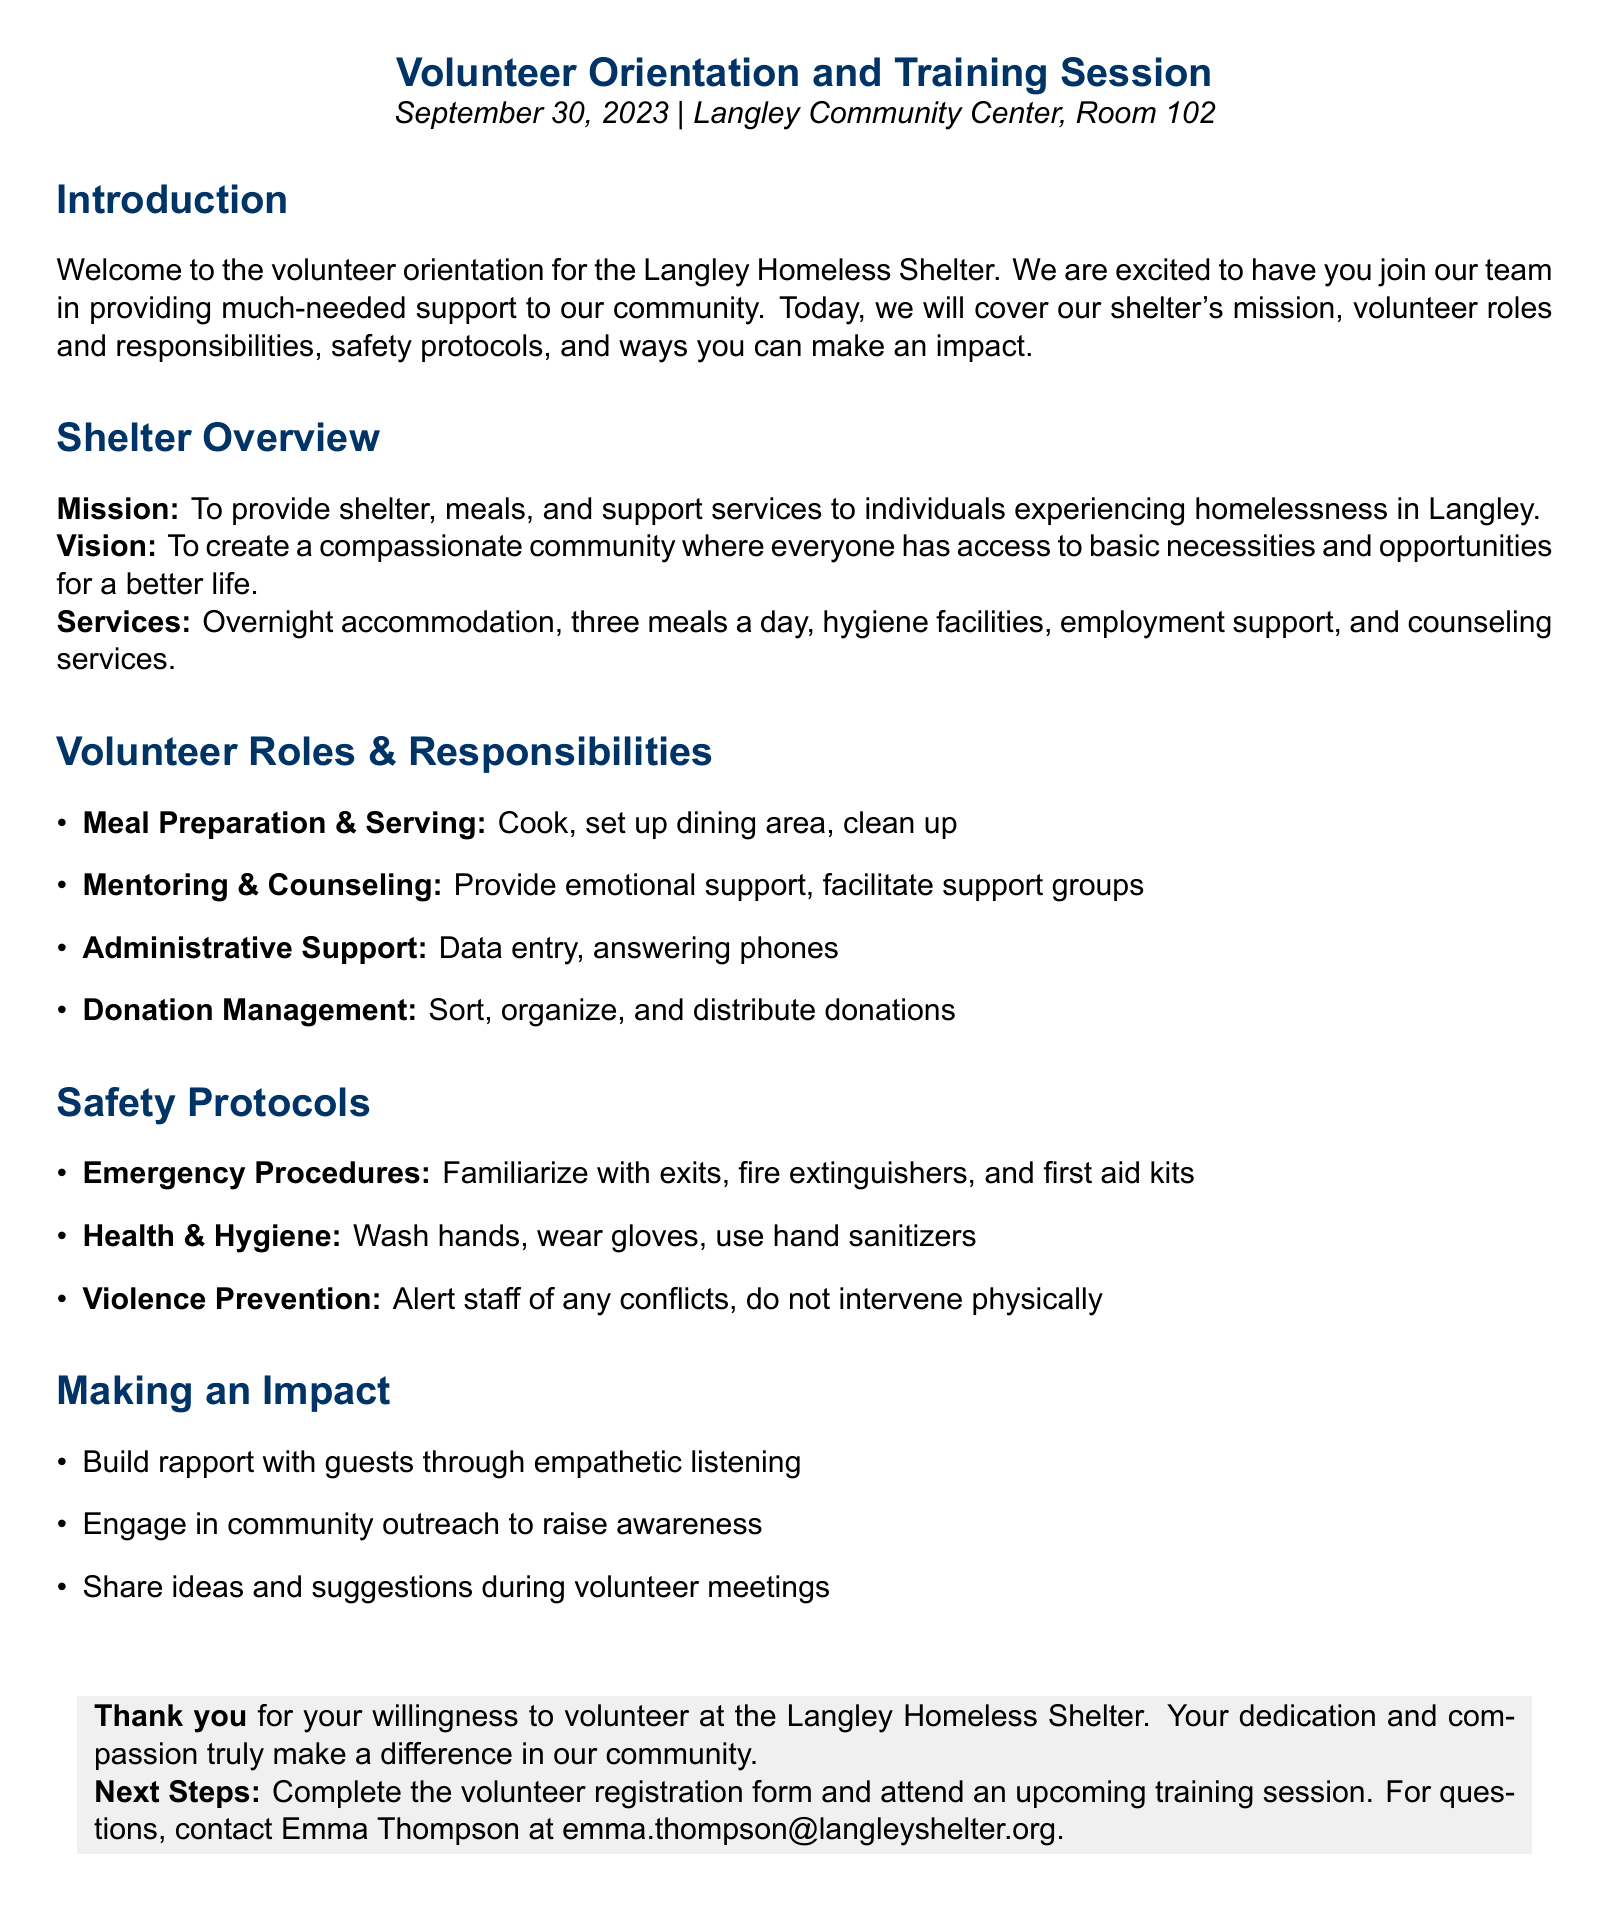What is the date of the orientation? The orientation is scheduled for September 30, 2023.
Answer: September 30, 2023 What is the mission of the shelter? The mission is to provide shelter, meals, and support services to individuals experiencing homelessness in Langley.
Answer: To provide shelter, meals, and support services What role involves cooking and serving food? This role is categorized under Meal Preparation & Serving.
Answer: Meal Preparation & Serving Who should you contact for questions? The contact person for questions is Emma Thompson.
Answer: Emma Thompson What type of support does the shelter offer? Services include overnight accommodation, three meals a day, hygiene facilities, employment support, and counseling services.
Answer: Overnight accommodation, three meals a day, hygiene facilities, employment support, and counseling services What should volunteers familiarize themselves with during emergency procedures? Volunteers should familiarize themselves with exits, fire extinguishers, and first aid kits.
Answer: Exits, fire extinguishers, and first aid kits What is one way volunteers can make an impact? One way to make an impact is to build rapport with guests through empathetic listening.
Answer: Build rapport with guests through empathetic listening What is required to proceed after the orientation? Volunteers must complete the volunteer registration form and attend a training session.
Answer: Complete the volunteer registration form and attend a training session 